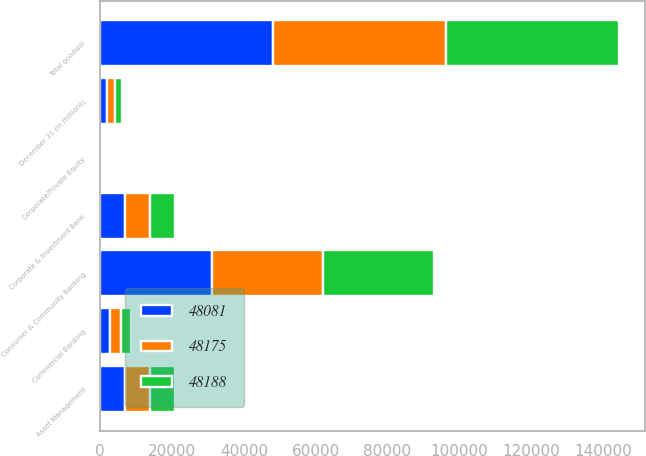<chart> <loc_0><loc_0><loc_500><loc_500><stacked_bar_chart><ecel><fcel>December 31 (in millions)<fcel>Consumer & Community Banking<fcel>Corporate & Investment Bank<fcel>Commercial Banking<fcel>Asset Management<fcel>Corporate/Private Equity<fcel>Total goodwill<nl><fcel>48175<fcel>2013<fcel>30985<fcel>6888<fcel>2862<fcel>6969<fcel>377<fcel>48081<nl><fcel>48188<fcel>2012<fcel>31048<fcel>6895<fcel>2863<fcel>6992<fcel>377<fcel>48175<nl><fcel>48081<fcel>2011<fcel>30996<fcel>6944<fcel>2864<fcel>7007<fcel>377<fcel>48188<nl></chart> 